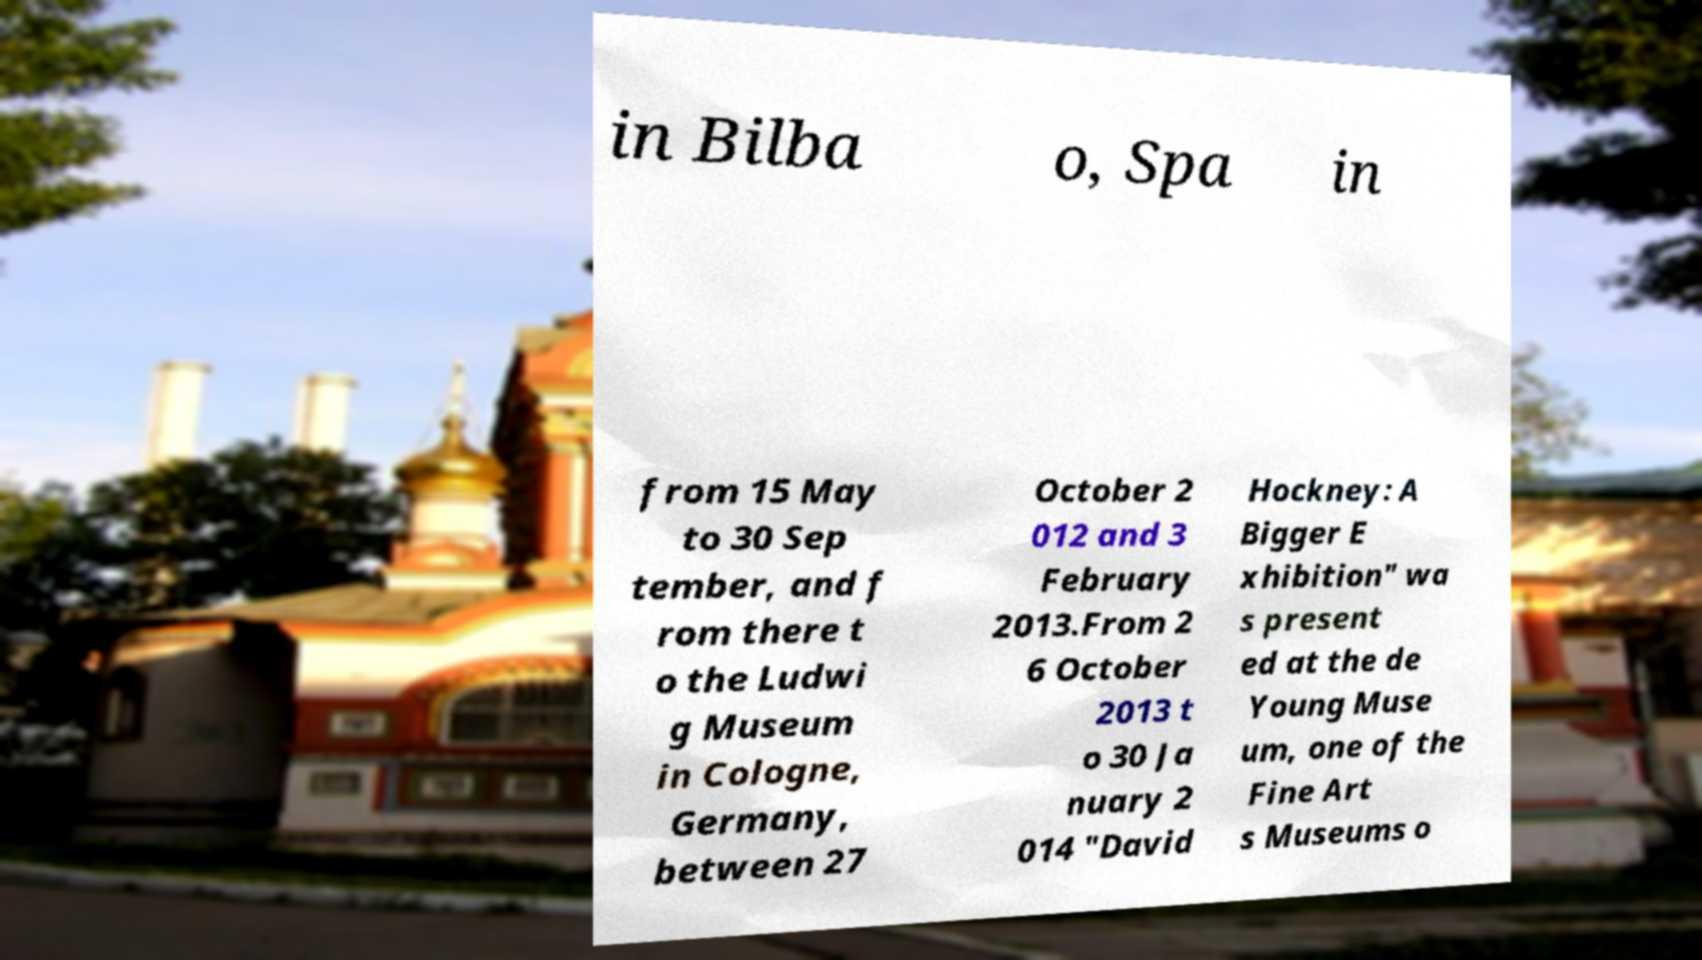I need the written content from this picture converted into text. Can you do that? in Bilba o, Spa in from 15 May to 30 Sep tember, and f rom there t o the Ludwi g Museum in Cologne, Germany, between 27 October 2 012 and 3 February 2013.From 2 6 October 2013 t o 30 Ja nuary 2 014 "David Hockney: A Bigger E xhibition" wa s present ed at the de Young Muse um, one of the Fine Art s Museums o 